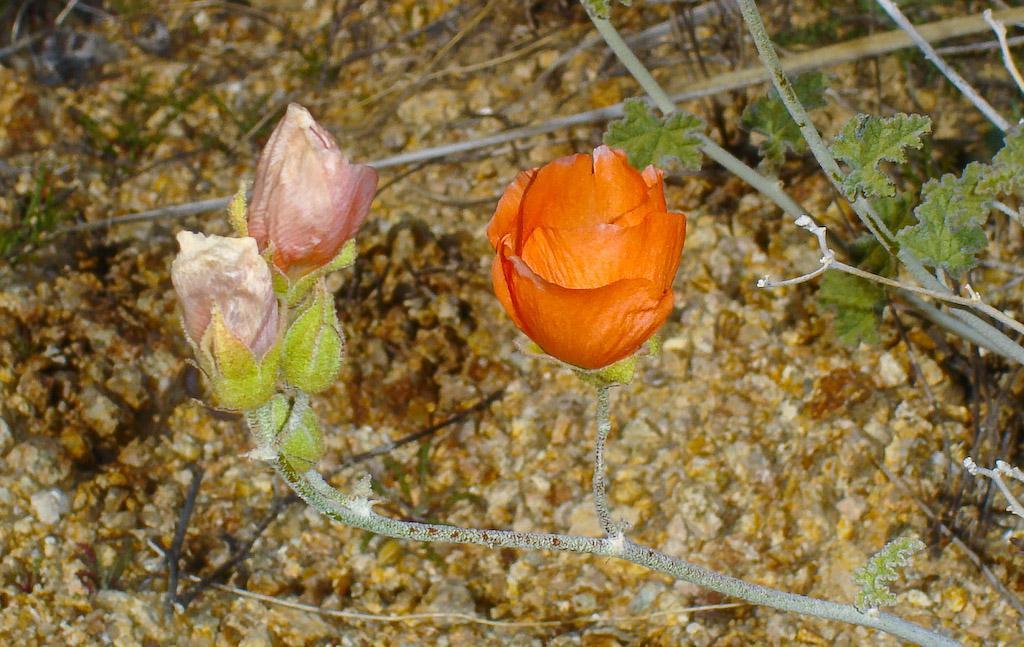Please provide a concise description of this image. In this picture we can see few flowers and plants. 